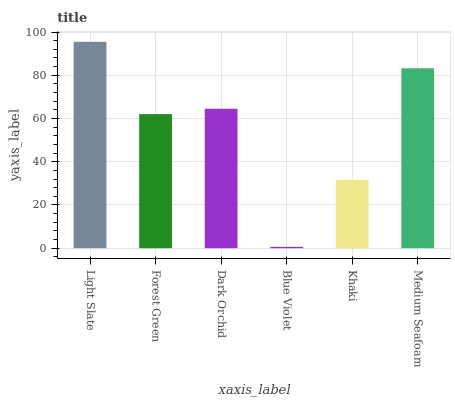Is Blue Violet the minimum?
Answer yes or no. Yes. Is Light Slate the maximum?
Answer yes or no. Yes. Is Forest Green the minimum?
Answer yes or no. No. Is Forest Green the maximum?
Answer yes or no. No. Is Light Slate greater than Forest Green?
Answer yes or no. Yes. Is Forest Green less than Light Slate?
Answer yes or no. Yes. Is Forest Green greater than Light Slate?
Answer yes or no. No. Is Light Slate less than Forest Green?
Answer yes or no. No. Is Dark Orchid the high median?
Answer yes or no. Yes. Is Forest Green the low median?
Answer yes or no. Yes. Is Khaki the high median?
Answer yes or no. No. Is Blue Violet the low median?
Answer yes or no. No. 